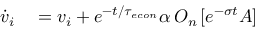<formula> <loc_0><loc_0><loc_500><loc_500>\begin{array} { r l } { \dot { v } _ { i } } & = v _ { i } + e ^ { - t / { \tau _ { e c o n } } } \alpha \, O _ { n } \left [ e ^ { - \sigma t } A \right ] } \end{array}</formula> 